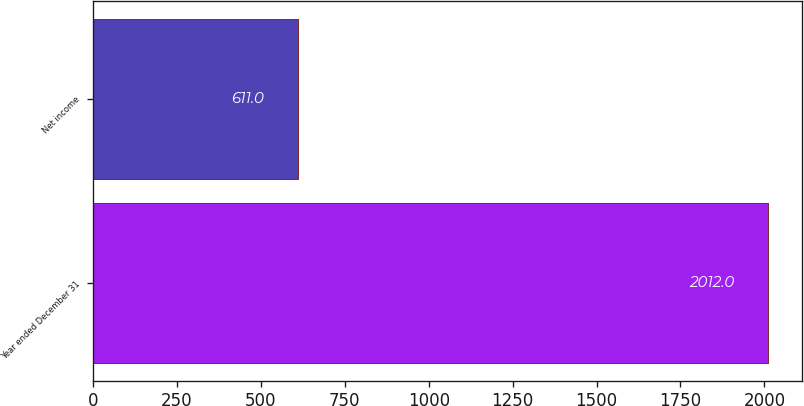Convert chart. <chart><loc_0><loc_0><loc_500><loc_500><bar_chart><fcel>Year ended December 31<fcel>Net income<nl><fcel>2012<fcel>611<nl></chart> 